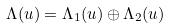Convert formula to latex. <formula><loc_0><loc_0><loc_500><loc_500>\Lambda ( u ) = \Lambda _ { 1 } ( u ) \oplus \Lambda _ { 2 } ( u )</formula> 